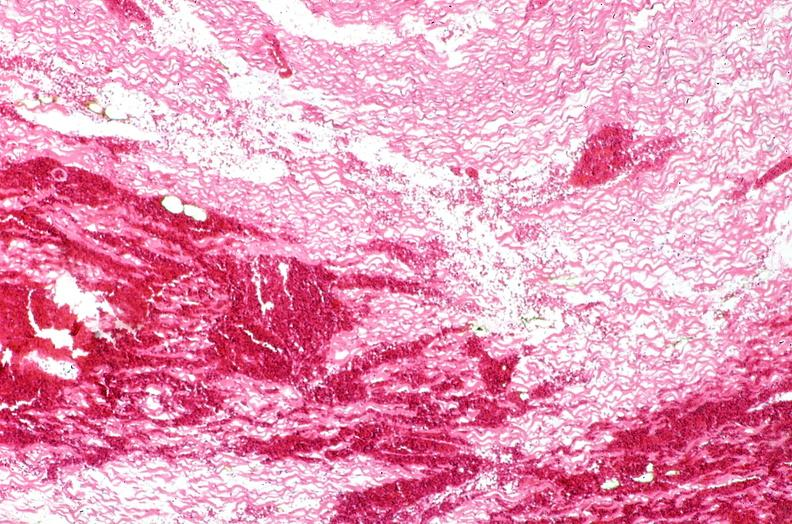s heart present?
Answer the question using a single word or phrase. Yes 